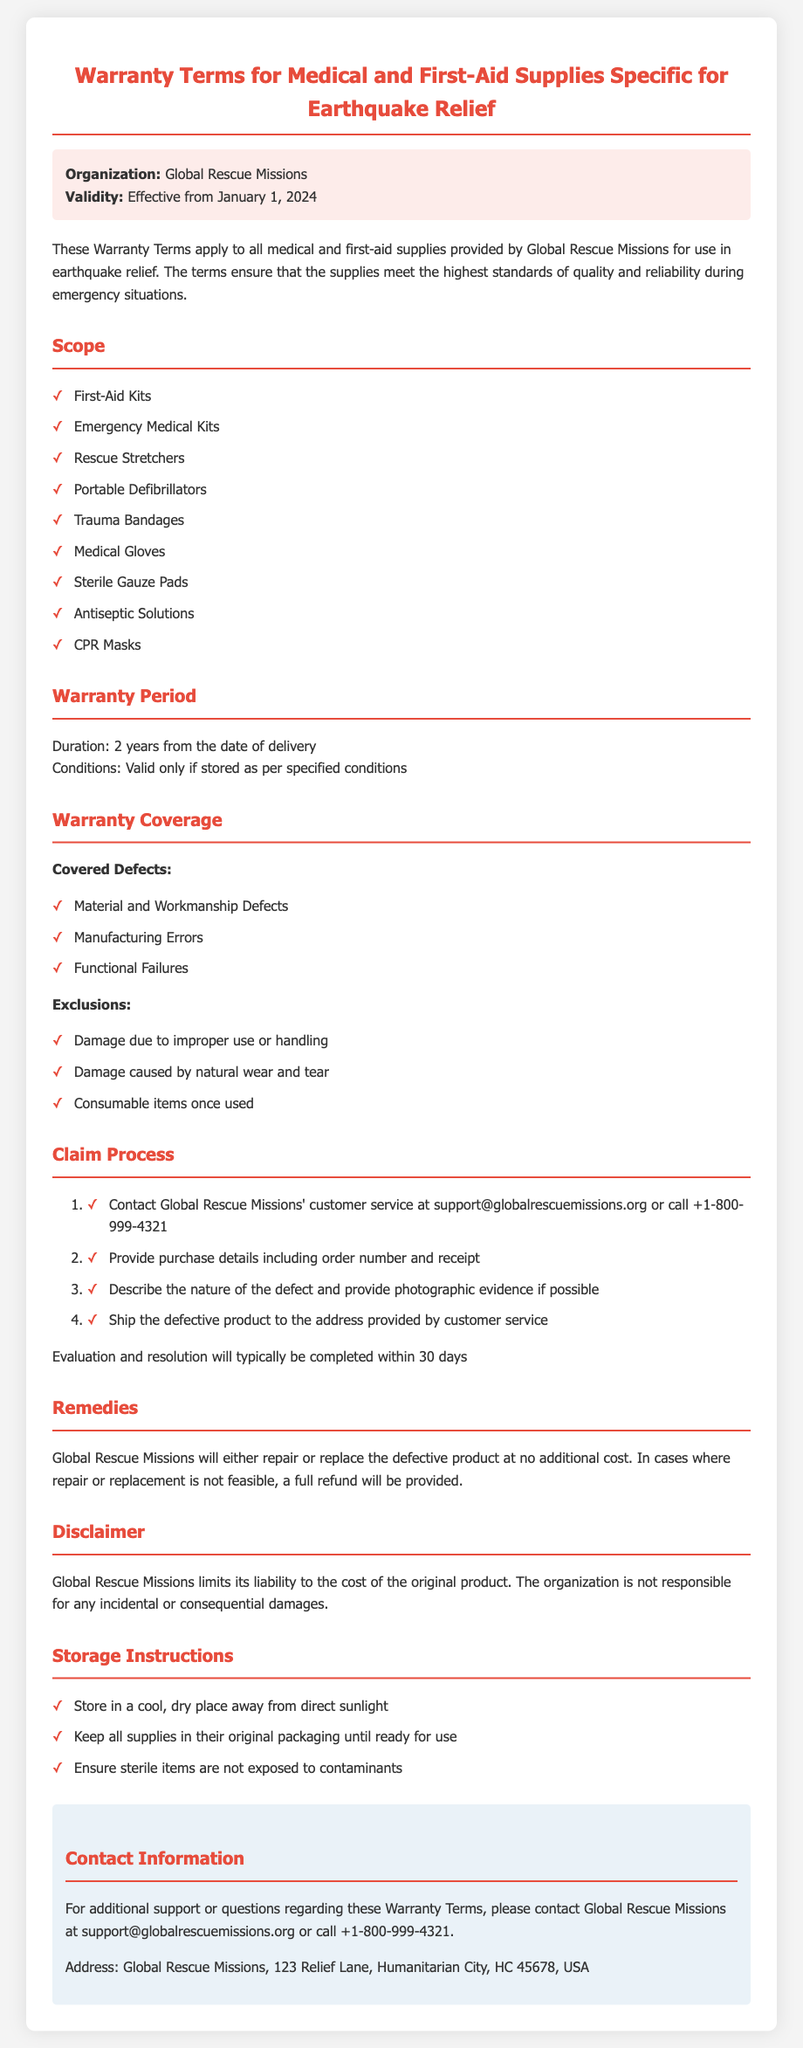What is the organization name? The organization's name is mentioned at the beginning of the document.
Answer: Global Rescue Missions What is the warranty period? The warranty period states how long the warranty is valid after delivery.
Answer: 2 years What should be provided when making a warranty claim? The document outlines the necessary details required for a warranty claim.
Answer: Purchase details including order number and receipt What types of defects are covered under the warranty? The document lists specific types of defects that are covered.
Answer: Material and Workmanship Defects, Manufacturing Errors, Functional Failures What exclusions are mentioned in the warranty coverage? Exclusions specify what is not covered under the warranty.
Answer: Damage due to improper use or handling, Damage caused by natural wear and tear, Consumable items once used What is the contact email for Global Rescue Missions? The document provides the email address for customer service inquiries.
Answer: support@globalrescuemissions.org How long does it typically take to resolve a claim? The document mentions the evaluation and resolution timeline for claims.
Answer: 30 days Where should defective products be shipped? The document indicates the process for returning defective products.
Answer: Address provided by customer service 